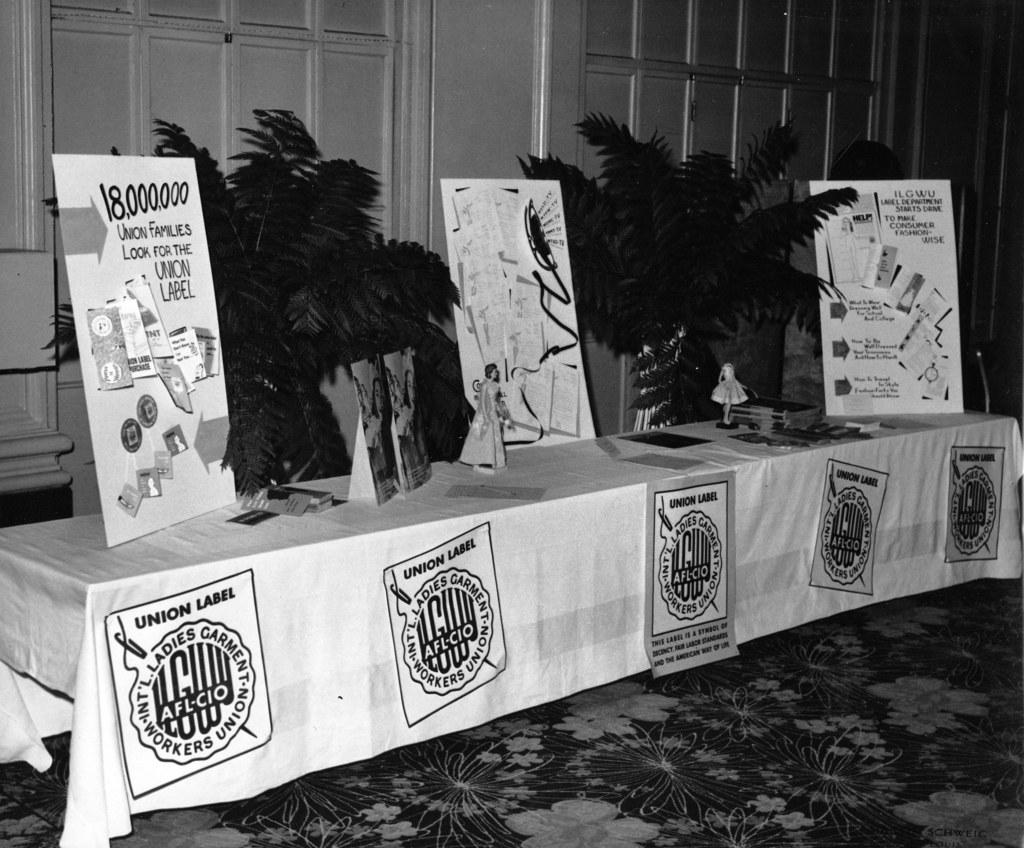<image>
Describe the image concisely. A table of handouts and souvenirs has AFL-CIO banners hanging from it. 